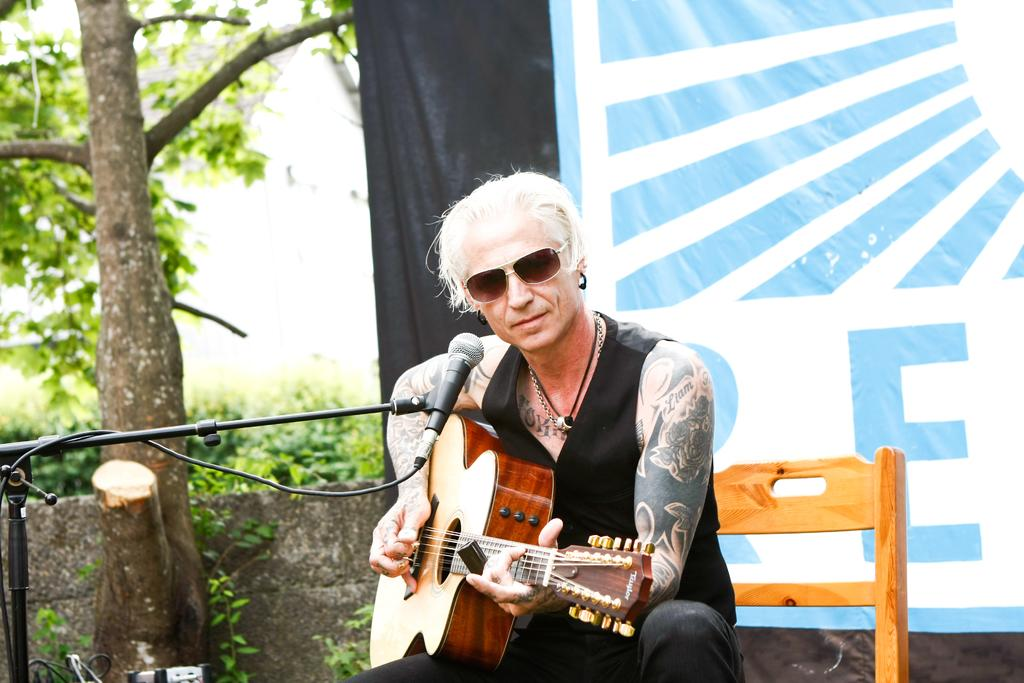What is the man in the image doing? The man is sitting on a chair and playing a guitar. What can be seen behind the man? There is a banner behind the man. What is located on the left side of the image? There is a tree, plants, and a microphone with a stand on the left side of the image. What type of metal is the mailbox made of in the image? There is no mailbox present in the image. 